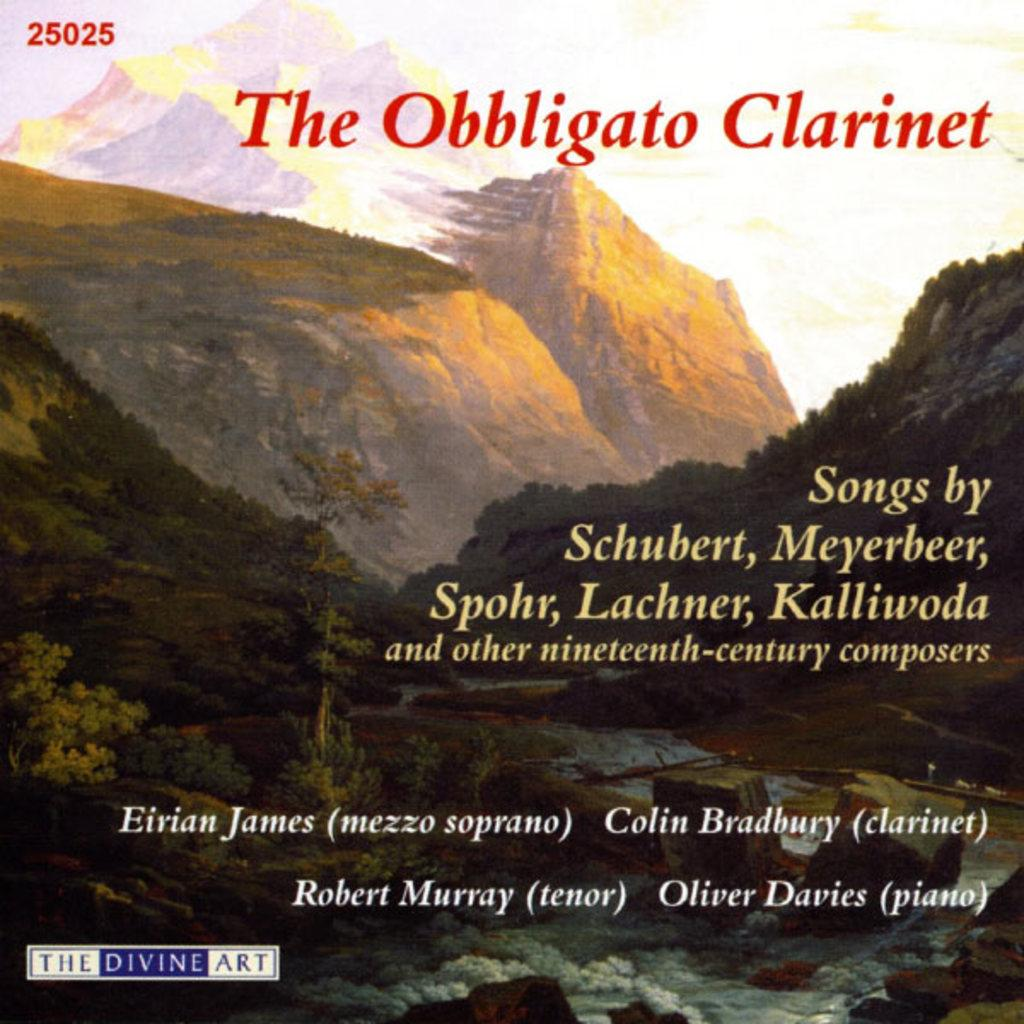<image>
Relay a brief, clear account of the picture shown. An album cover for "The Obbligato Clarinet" with songs by many different composers. 